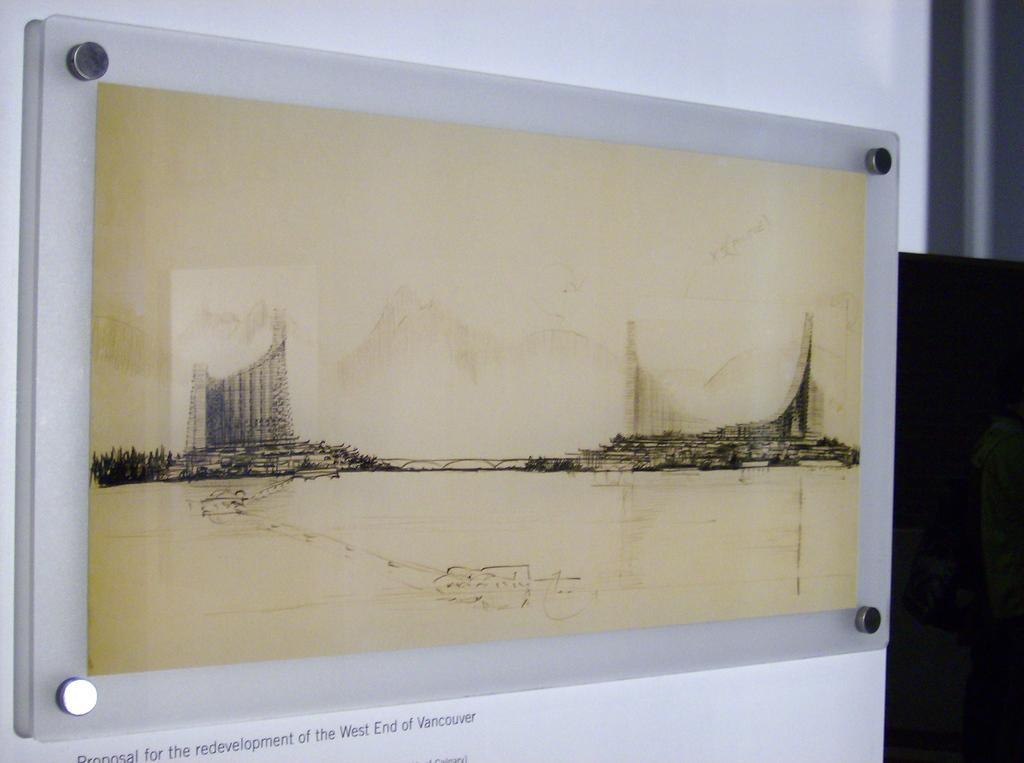How would you summarize this image in a sentence or two? This is a photo frame fixed to the wall. There are buildings in this photo. 